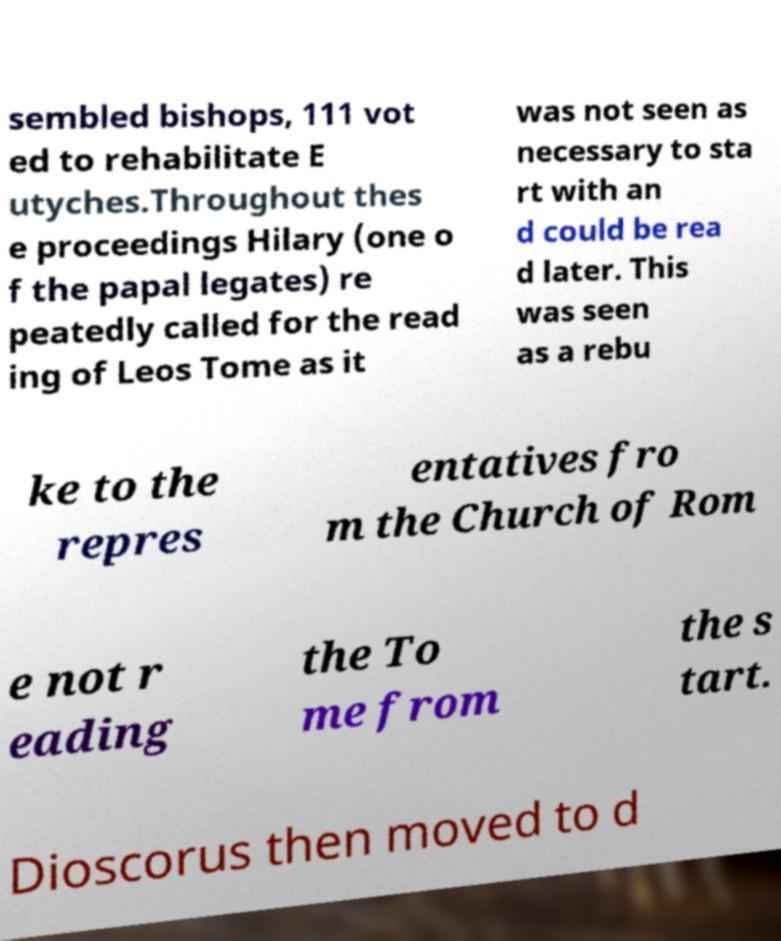Please read and relay the text visible in this image. What does it say? sembled bishops, 111 vot ed to rehabilitate E utyches.Throughout thes e proceedings Hilary (one o f the papal legates) re peatedly called for the read ing of Leos Tome as it was not seen as necessary to sta rt with an d could be rea d later. This was seen as a rebu ke to the repres entatives fro m the Church of Rom e not r eading the To me from the s tart. Dioscorus then moved to d 